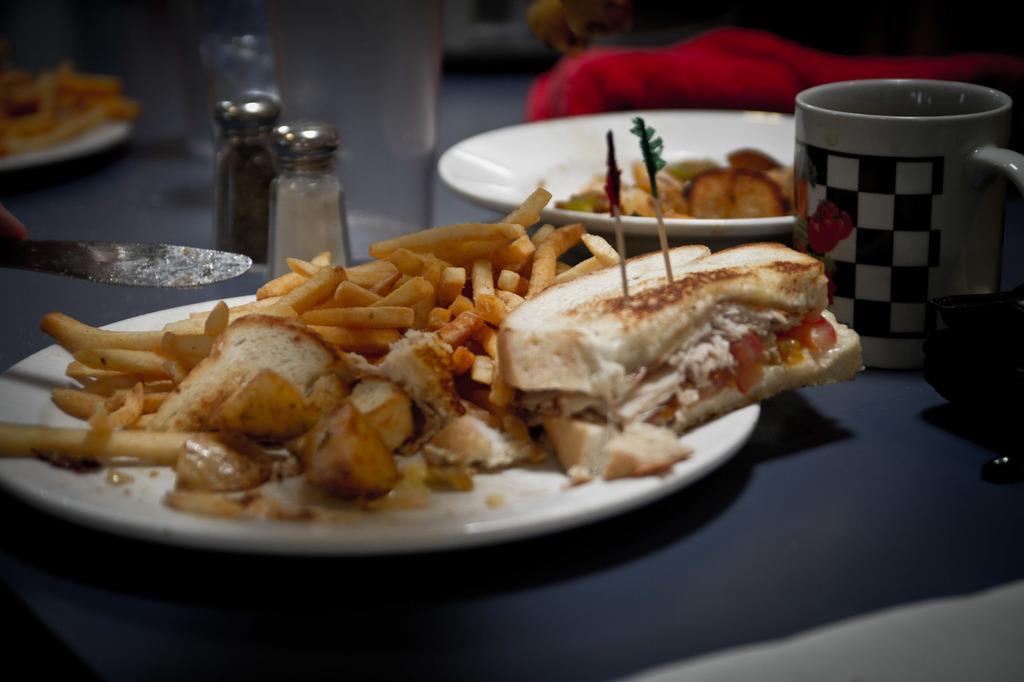What type of objects can be seen on the platform in the image? There are plates with food items, a cup, jars, a knife, and a glass on the platform in the image. What might be used for drinking in the image? The cup and glass in the image can be used for drinking. What can be used for cutting in the image? There is a knife in the image that can be used for cutting. What question is being asked by the plate in the image? There is no plate present in the image that can ask a question. 